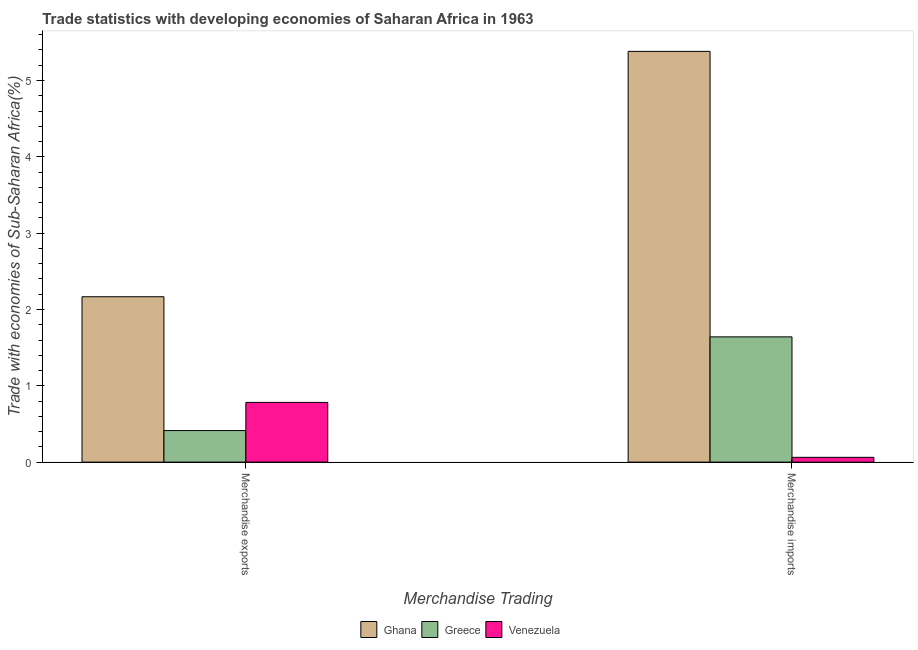How many different coloured bars are there?
Provide a short and direct response. 3. Are the number of bars per tick equal to the number of legend labels?
Provide a succinct answer. Yes. Are the number of bars on each tick of the X-axis equal?
Provide a succinct answer. Yes. How many bars are there on the 2nd tick from the right?
Your answer should be very brief. 3. What is the merchandise imports in Venezuela?
Provide a short and direct response. 0.06. Across all countries, what is the maximum merchandise imports?
Make the answer very short. 5.38. Across all countries, what is the minimum merchandise imports?
Provide a succinct answer. 0.06. In which country was the merchandise exports maximum?
Give a very brief answer. Ghana. In which country was the merchandise imports minimum?
Your answer should be very brief. Venezuela. What is the total merchandise exports in the graph?
Ensure brevity in your answer.  3.36. What is the difference between the merchandise imports in Ghana and that in Venezuela?
Keep it short and to the point. 5.32. What is the difference between the merchandise imports in Ghana and the merchandise exports in Venezuela?
Provide a succinct answer. 4.6. What is the average merchandise exports per country?
Provide a succinct answer. 1.12. What is the difference between the merchandise exports and merchandise imports in Venezuela?
Provide a short and direct response. 0.72. In how many countries, is the merchandise imports greater than 1.6 %?
Your response must be concise. 2. What is the ratio of the merchandise imports in Venezuela to that in Greece?
Your answer should be very brief. 0.04. What does the 3rd bar from the right in Merchandise imports represents?
Keep it short and to the point. Ghana. How many legend labels are there?
Offer a terse response. 3. How are the legend labels stacked?
Provide a short and direct response. Horizontal. What is the title of the graph?
Keep it short and to the point. Trade statistics with developing economies of Saharan Africa in 1963. What is the label or title of the X-axis?
Make the answer very short. Merchandise Trading. What is the label or title of the Y-axis?
Make the answer very short. Trade with economies of Sub-Saharan Africa(%). What is the Trade with economies of Sub-Saharan Africa(%) in Ghana in Merchandise exports?
Keep it short and to the point. 2.17. What is the Trade with economies of Sub-Saharan Africa(%) of Greece in Merchandise exports?
Your answer should be compact. 0.41. What is the Trade with economies of Sub-Saharan Africa(%) in Venezuela in Merchandise exports?
Your answer should be very brief. 0.78. What is the Trade with economies of Sub-Saharan Africa(%) in Ghana in Merchandise imports?
Offer a very short reply. 5.38. What is the Trade with economies of Sub-Saharan Africa(%) of Greece in Merchandise imports?
Your answer should be very brief. 1.64. What is the Trade with economies of Sub-Saharan Africa(%) of Venezuela in Merchandise imports?
Offer a very short reply. 0.06. Across all Merchandise Trading, what is the maximum Trade with economies of Sub-Saharan Africa(%) of Ghana?
Provide a succinct answer. 5.38. Across all Merchandise Trading, what is the maximum Trade with economies of Sub-Saharan Africa(%) of Greece?
Give a very brief answer. 1.64. Across all Merchandise Trading, what is the maximum Trade with economies of Sub-Saharan Africa(%) in Venezuela?
Your answer should be compact. 0.78. Across all Merchandise Trading, what is the minimum Trade with economies of Sub-Saharan Africa(%) in Ghana?
Give a very brief answer. 2.17. Across all Merchandise Trading, what is the minimum Trade with economies of Sub-Saharan Africa(%) in Greece?
Your response must be concise. 0.41. Across all Merchandise Trading, what is the minimum Trade with economies of Sub-Saharan Africa(%) in Venezuela?
Keep it short and to the point. 0.06. What is the total Trade with economies of Sub-Saharan Africa(%) of Ghana in the graph?
Your response must be concise. 7.55. What is the total Trade with economies of Sub-Saharan Africa(%) in Greece in the graph?
Give a very brief answer. 2.05. What is the total Trade with economies of Sub-Saharan Africa(%) in Venezuela in the graph?
Offer a very short reply. 0.85. What is the difference between the Trade with economies of Sub-Saharan Africa(%) of Ghana in Merchandise exports and that in Merchandise imports?
Provide a succinct answer. -3.21. What is the difference between the Trade with economies of Sub-Saharan Africa(%) in Greece in Merchandise exports and that in Merchandise imports?
Your response must be concise. -1.23. What is the difference between the Trade with economies of Sub-Saharan Africa(%) of Venezuela in Merchandise exports and that in Merchandise imports?
Your response must be concise. 0.72. What is the difference between the Trade with economies of Sub-Saharan Africa(%) of Ghana in Merchandise exports and the Trade with economies of Sub-Saharan Africa(%) of Greece in Merchandise imports?
Offer a very short reply. 0.53. What is the difference between the Trade with economies of Sub-Saharan Africa(%) in Ghana in Merchandise exports and the Trade with economies of Sub-Saharan Africa(%) in Venezuela in Merchandise imports?
Offer a very short reply. 2.1. What is the difference between the Trade with economies of Sub-Saharan Africa(%) in Greece in Merchandise exports and the Trade with economies of Sub-Saharan Africa(%) in Venezuela in Merchandise imports?
Provide a succinct answer. 0.35. What is the average Trade with economies of Sub-Saharan Africa(%) of Ghana per Merchandise Trading?
Give a very brief answer. 3.77. What is the average Trade with economies of Sub-Saharan Africa(%) of Greece per Merchandise Trading?
Provide a short and direct response. 1.03. What is the average Trade with economies of Sub-Saharan Africa(%) of Venezuela per Merchandise Trading?
Your answer should be compact. 0.42. What is the difference between the Trade with economies of Sub-Saharan Africa(%) of Ghana and Trade with economies of Sub-Saharan Africa(%) of Greece in Merchandise exports?
Make the answer very short. 1.75. What is the difference between the Trade with economies of Sub-Saharan Africa(%) of Ghana and Trade with economies of Sub-Saharan Africa(%) of Venezuela in Merchandise exports?
Give a very brief answer. 1.38. What is the difference between the Trade with economies of Sub-Saharan Africa(%) of Greece and Trade with economies of Sub-Saharan Africa(%) of Venezuela in Merchandise exports?
Provide a succinct answer. -0.37. What is the difference between the Trade with economies of Sub-Saharan Africa(%) in Ghana and Trade with economies of Sub-Saharan Africa(%) in Greece in Merchandise imports?
Give a very brief answer. 3.74. What is the difference between the Trade with economies of Sub-Saharan Africa(%) of Ghana and Trade with economies of Sub-Saharan Africa(%) of Venezuela in Merchandise imports?
Your response must be concise. 5.32. What is the difference between the Trade with economies of Sub-Saharan Africa(%) in Greece and Trade with economies of Sub-Saharan Africa(%) in Venezuela in Merchandise imports?
Offer a very short reply. 1.58. What is the ratio of the Trade with economies of Sub-Saharan Africa(%) of Ghana in Merchandise exports to that in Merchandise imports?
Your response must be concise. 0.4. What is the ratio of the Trade with economies of Sub-Saharan Africa(%) in Greece in Merchandise exports to that in Merchandise imports?
Your response must be concise. 0.25. What is the ratio of the Trade with economies of Sub-Saharan Africa(%) of Venezuela in Merchandise exports to that in Merchandise imports?
Offer a terse response. 12.45. What is the difference between the highest and the second highest Trade with economies of Sub-Saharan Africa(%) in Ghana?
Your response must be concise. 3.21. What is the difference between the highest and the second highest Trade with economies of Sub-Saharan Africa(%) of Greece?
Give a very brief answer. 1.23. What is the difference between the highest and the second highest Trade with economies of Sub-Saharan Africa(%) of Venezuela?
Offer a very short reply. 0.72. What is the difference between the highest and the lowest Trade with economies of Sub-Saharan Africa(%) of Ghana?
Offer a very short reply. 3.21. What is the difference between the highest and the lowest Trade with economies of Sub-Saharan Africa(%) in Greece?
Keep it short and to the point. 1.23. What is the difference between the highest and the lowest Trade with economies of Sub-Saharan Africa(%) of Venezuela?
Your answer should be compact. 0.72. 